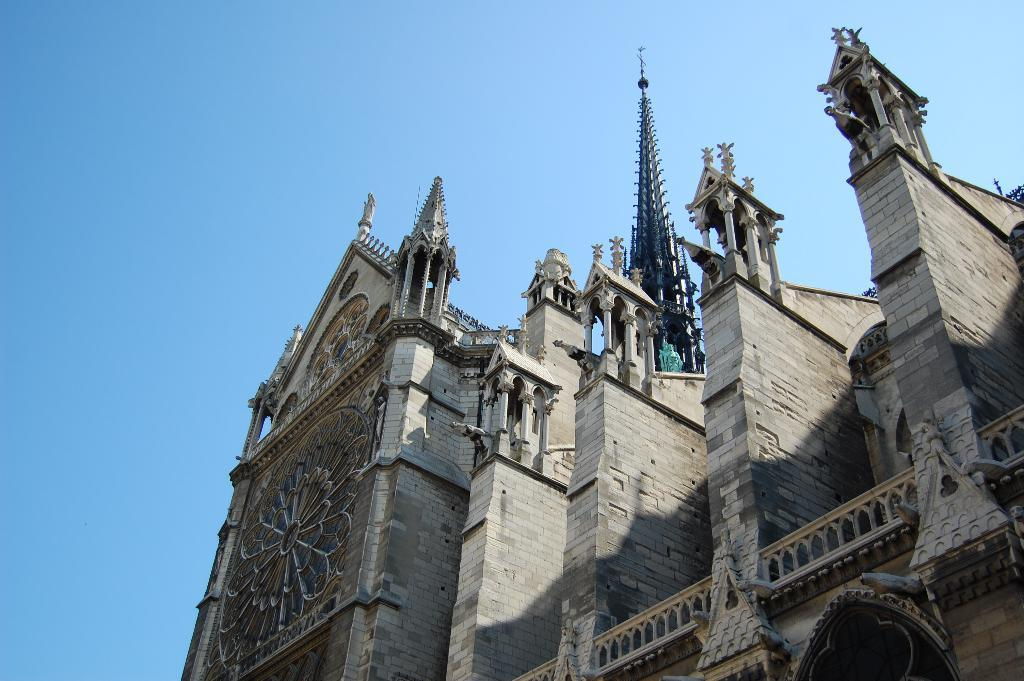What type of structure is present in the image? There is a building in the image. What architectural features can be seen in the image? There are pillars and walls visible in the image. What is visible in the background of the image? The sky is visible in the background of the image. Is there a rainstorm happening in the image? There is no indication of a rainstorm in the image; it appears to be a clear day based on the visible sky. Can you see a turkey in the image? There is no turkey present in the image. 